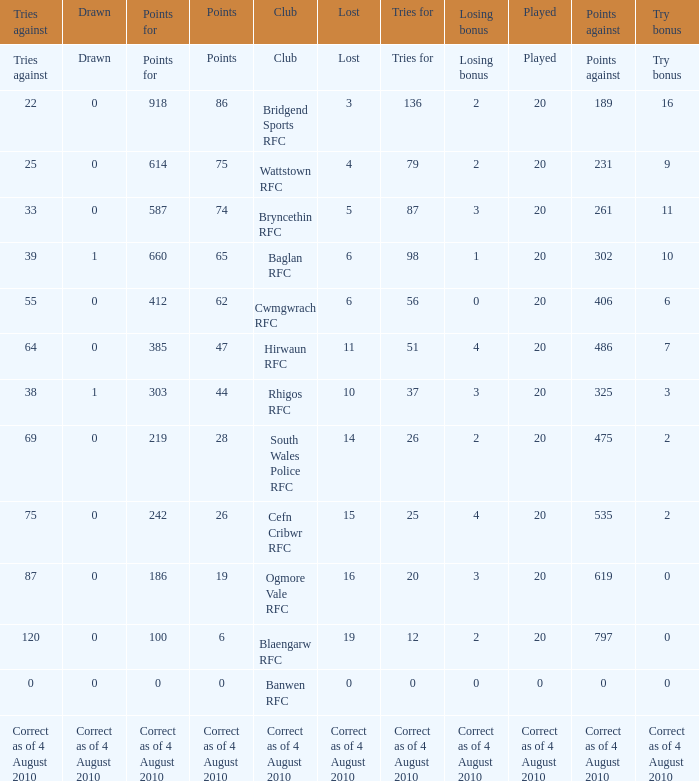What is the tries fow when losing bonus is losing bonus? Tries for. 